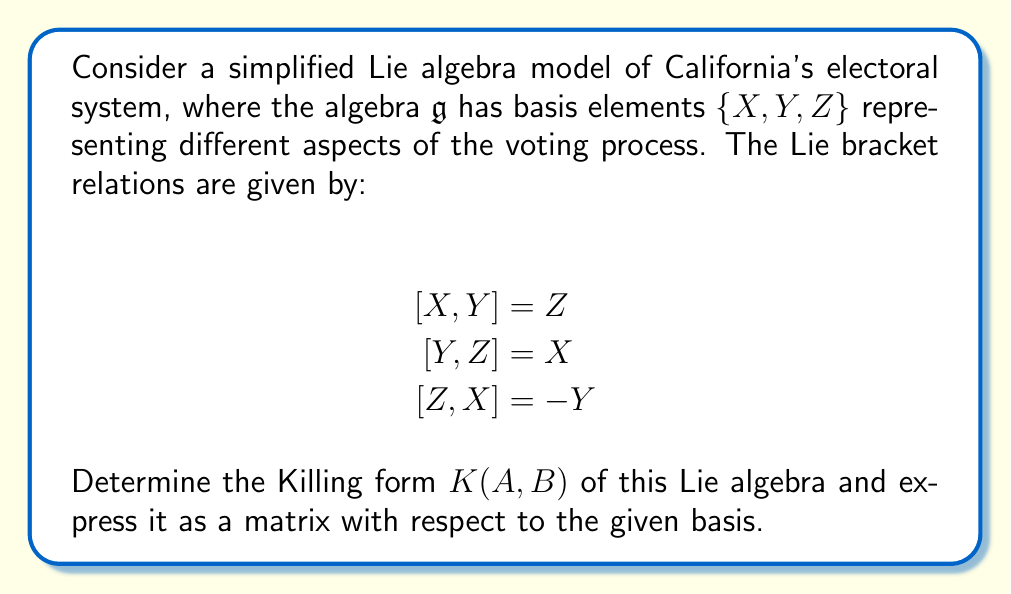Show me your answer to this math problem. To find the Killing form of the given Lie algebra, we need to follow these steps:

1) The Killing form is defined as $K(A, B) = \text{tr}(\text{ad}_A \circ \text{ad}_B)$, where $\text{ad}_A$ is the adjoint representation of $A$.

2) First, we need to find the matrices of the adjoint representations for each basis element:

   For $X$: $\text{ad}_X(Y) = [X,Y] = Z$, $\text{ad}_X(Z) = [X,Z] = Y$
   $$\text{ad}_X = \begin{pmatrix}
   0 & 0 & 0 \\
   0 & 0 & -1 \\
   0 & 1 & 0
   \end{pmatrix}$$

   For $Y$: $\text{ad}_Y(X) = [Y,X] = -Z$, $\text{ad}_Y(Z) = [Y,Z] = X$
   $$\text{ad}_Y = \begin{pmatrix}
   0 & 0 & 1 \\
   0 & 0 & 0 \\
   -1 & 0 & 0
   \end{pmatrix}$$

   For $Z$: $\text{ad}_Z(X) = [Z,X] = -Y$, $\text{ad}_Z(Y) = [Z,Y] = -X$
   $$\text{ad}_Z = \begin{pmatrix}
   0 & -1 & 0 \\
   1 & 0 & 0 \\
   0 & 0 & 0
   \end{pmatrix}$$

3) Now, we compute $K(A,B)$ for each pair of basis elements:

   $K(X,X) = \text{tr}(\text{ad}_X \circ \text{ad}_X) = -2$
   $K(Y,Y) = \text{tr}(\text{ad}_Y \circ \text{ad}_Y) = -2$
   $K(Z,Z) = \text{tr}(\text{ad}_Z \circ \text{ad}_Z) = -2$

   $K(X,Y) = K(Y,X) = \text{tr}(\text{ad}_X \circ \text{ad}_Y) = 0$
   $K(X,Z) = K(Z,X) = \text{tr}(\text{ad}_X \circ \text{ad}_Z) = 0$
   $K(Y,Z) = K(Z,Y) = \text{tr}(\text{ad}_Y \circ \text{ad}_Z) = 0$

4) The Killing form can be represented as a matrix with respect to the basis $\{X, Y, Z\}$:

   $$K = \begin{pmatrix}
   -2 & 0 & 0 \\
   0 & -2 & 0 \\
   0 & 0 & -2
   \end{pmatrix}$$

This matrix representation of the Killing form reflects the symmetry and simplicity of our model of California's electoral system, which might appeal to a Republican lawyer's preference for clear and straightforward structures.
Answer: The Killing form of the given Lie algebra, expressed as a matrix with respect to the basis $\{X, Y, Z\}$, is:

$$K = \begin{pmatrix}
-2 & 0 & 0 \\
0 & -2 & 0 \\
0 & 0 & -2
\end{pmatrix}$$ 